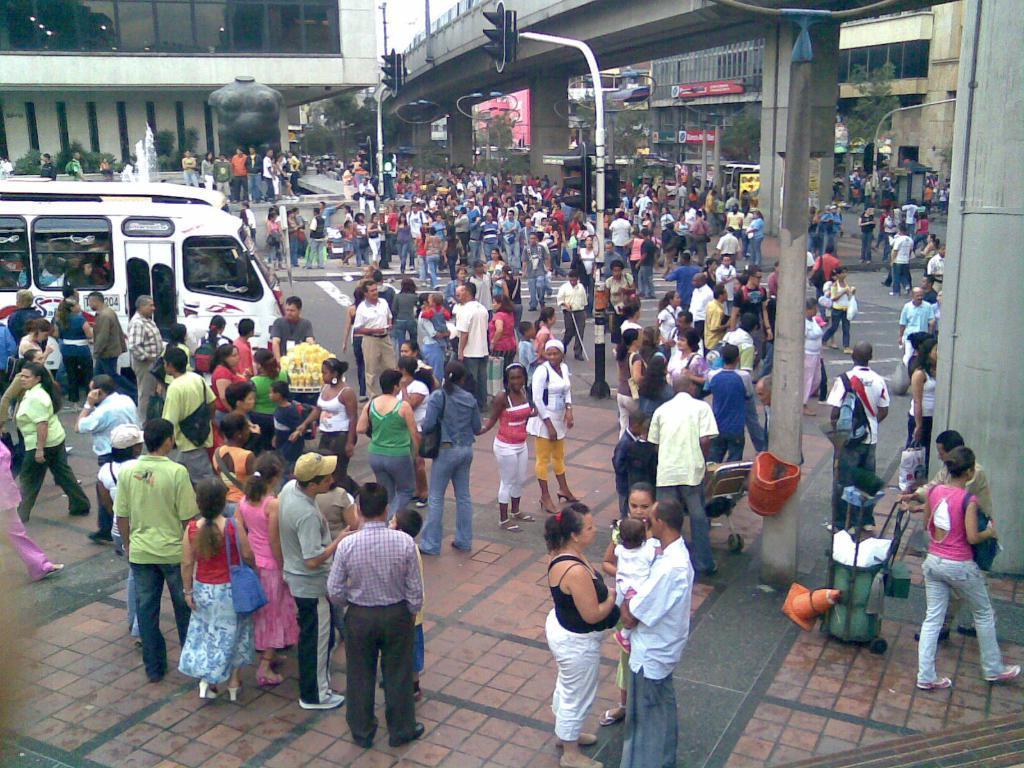Could you give a brief overview of what you see in this image? This picture is clicked outside. In the center we can see the group of persons, traffic lights, poles and many other objects. On the left we can see the vehicles. In the background we can see the buildings, lights, plants, trees, text on the boards and many other objects. 